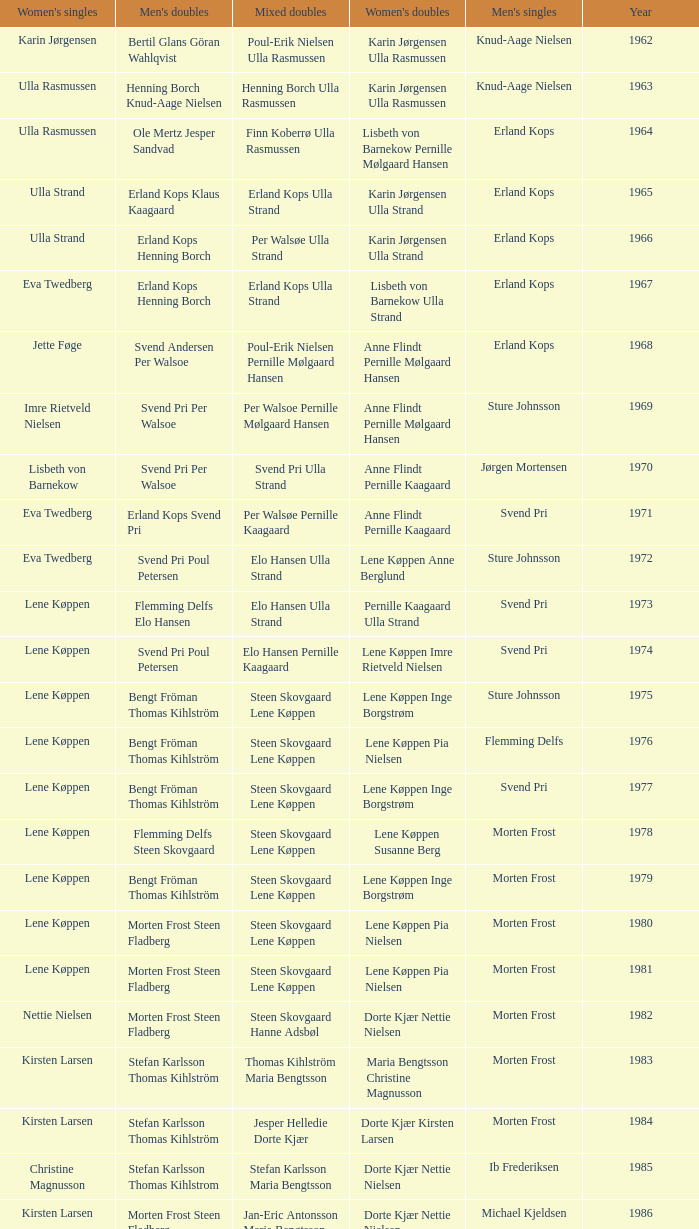Who won the men's doubles the year Pernille Nedergaard won the women's singles? Thomas Stuer-Lauridsen Max Gandrup. 